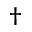<formula> <loc_0><loc_0><loc_500><loc_500>\dagger</formula> 